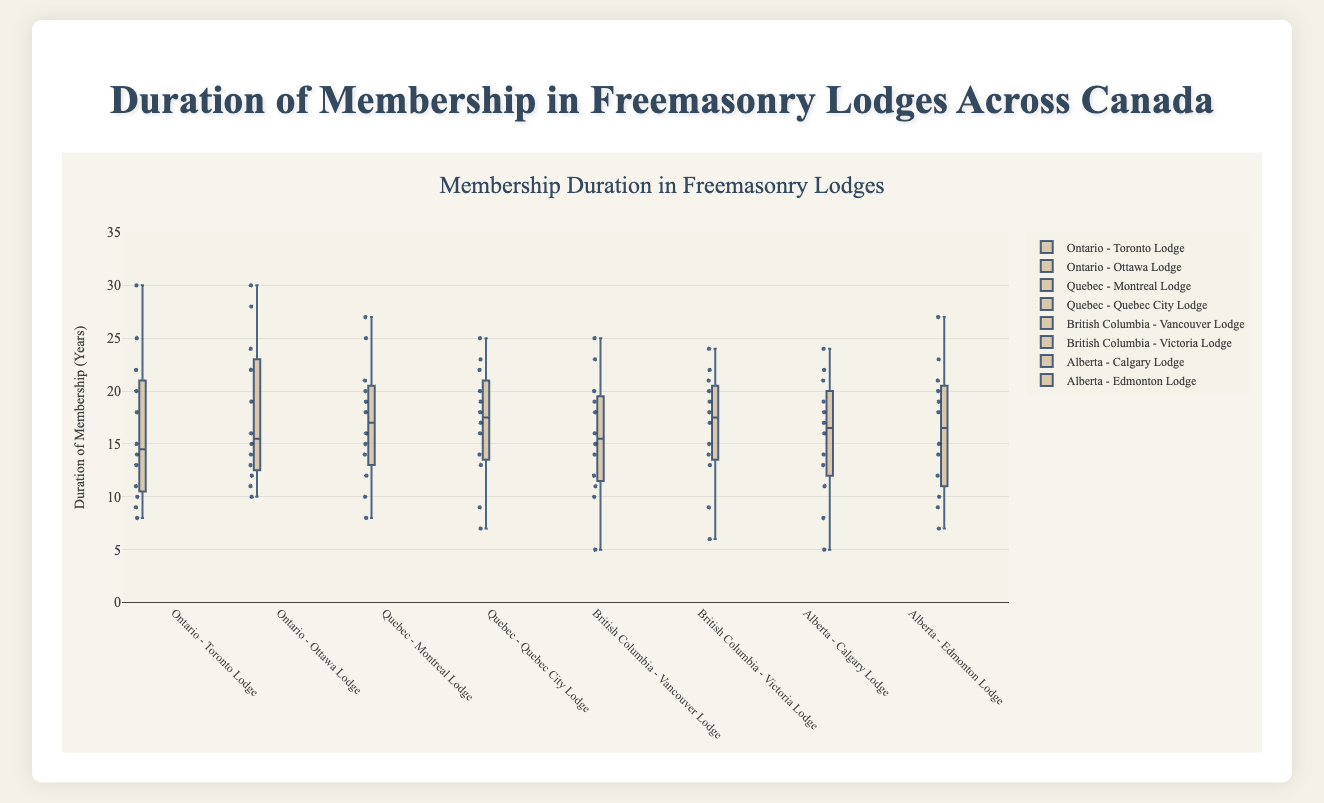What's the title of the plot? The title of the plot is typically found at the top of the figure. It is used to inform the viewer immediately about the subject of the plot. The title reads, "Duration of Membership in Freemasonry Lodges Across Canada."
Answer: "Duration of Membership in Freemasonry Lodges Across Canada" What is the range of membership durations shown on the y-axis? The y-axis represents the duration of membership in years. The axis range can be determined by observing the lowest and highest tick marks. The range is from 0 to 35 years.
Answer: 0 to 35 years Which lodge from Ontario has members with the longest membership duration? To find which lodge has the longest membership duration, observe the highest data points in the box plots for Ontario. Toronto Lodge has a member with a duration of 30 years, while Ottawa Lodge has a member with a duration of 30 years as well. Both lodges have the longest duration tied.
Answer: Both Toronto Lodge and Ottawa Lodge Which region has the maximum outliers in membership durations? Outliers are data points that are significantly different from other observations. They are typically marked differently in a box plot. By counting the outliers in each region, you can determine which region has the most. Ontario has the maximum number of outliers.
Answer: Ontario What is the median membership duration for Montreal Lodge? The median is typically illustrated by the line inside the central box of the box plot. For Montreal Lodge, this median line is positioned at 16 years.
Answer: 16 years How does the interquartile range (IQR) of Victoria Lodge compare to Calgary Lodge? The Interquartile Range (IQR) is the difference between the third quartile (Q3) and the first quartile (Q1) and indicates the spread of the middle 50% of data. Comparing the box sizes, Victoria Lodge has a slightly larger IQR than Calgary Lodge.
Answer: Victoria Lodge has a larger IQR Which lodge has the smallest range of membership durations? The range is calculated as the difference between the maximum and minimum values. Examining each box plot, the Vancouver Lodge has the smallest range since its data points are more closely packed compared to others.
Answer: Vancouver Lodge Are there any regions which have membership durations without any outliers? If yes, which ones? Outliers are usually marked as individual dots separate from the whiskers of the box plots. Quebec and Alberta regions do not show any outliers in their box plots.
Answer: Quebec and Alberta Compare the median membership duration of Toronto Lodge and Edmonton Lodge. Which one is higher? To determine which median is higher, compare the line inside the box for both lodges. The Toronto Lodge has a median of 14 years and the Edmonton Lodge has a median of 16 years. Thus, Edmonton Lodge's median is higher.
Answer: Edmonton Lodge 